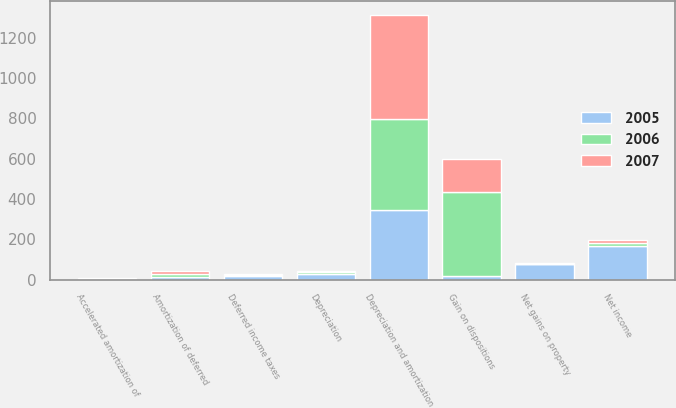<chart> <loc_0><loc_0><loc_500><loc_500><stacked_bar_chart><ecel><fcel>Net income<fcel>Gain on dispositions<fcel>Depreciation<fcel>Depreciation and amortization<fcel>Amortization of deferred<fcel>Deferred income taxes<fcel>Accelerated amortization of<fcel>Net gains on property<nl><fcel>2007<fcel>14.5<fcel>162<fcel>3<fcel>517<fcel>13<fcel>7<fcel>5<fcel>6<nl><fcel>2006<fcel>14.5<fcel>418<fcel>12<fcel>451<fcel>15<fcel>5<fcel>1<fcel>1<nl><fcel>2005<fcel>166<fcel>19<fcel>26<fcel>347<fcel>14<fcel>17<fcel>3<fcel>75<nl></chart> 